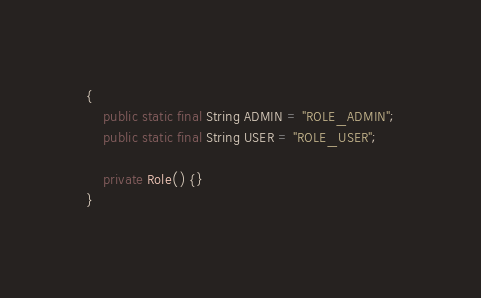Convert code to text. <code><loc_0><loc_0><loc_500><loc_500><_Java_>{
    public static final String ADMIN = "ROLE_ADMIN";
    public static final String USER = "ROLE_USER";

    private Role() {}
}
</code> 